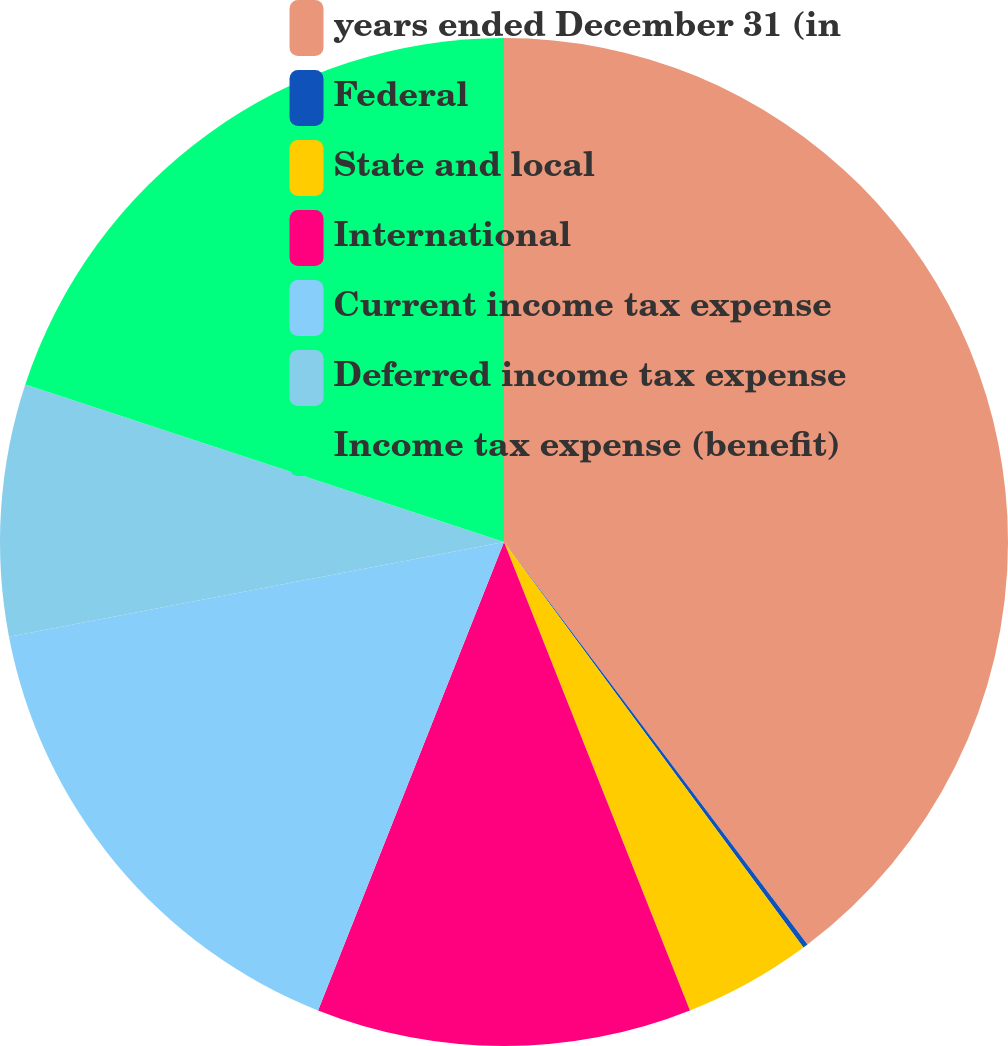Convert chart. <chart><loc_0><loc_0><loc_500><loc_500><pie_chart><fcel>years ended December 31 (in<fcel>Federal<fcel>State and local<fcel>International<fcel>Current income tax expense<fcel>Deferred income tax expense<fcel>Income tax expense (benefit)<nl><fcel>39.72%<fcel>0.16%<fcel>4.11%<fcel>12.03%<fcel>15.98%<fcel>8.07%<fcel>19.94%<nl></chart> 